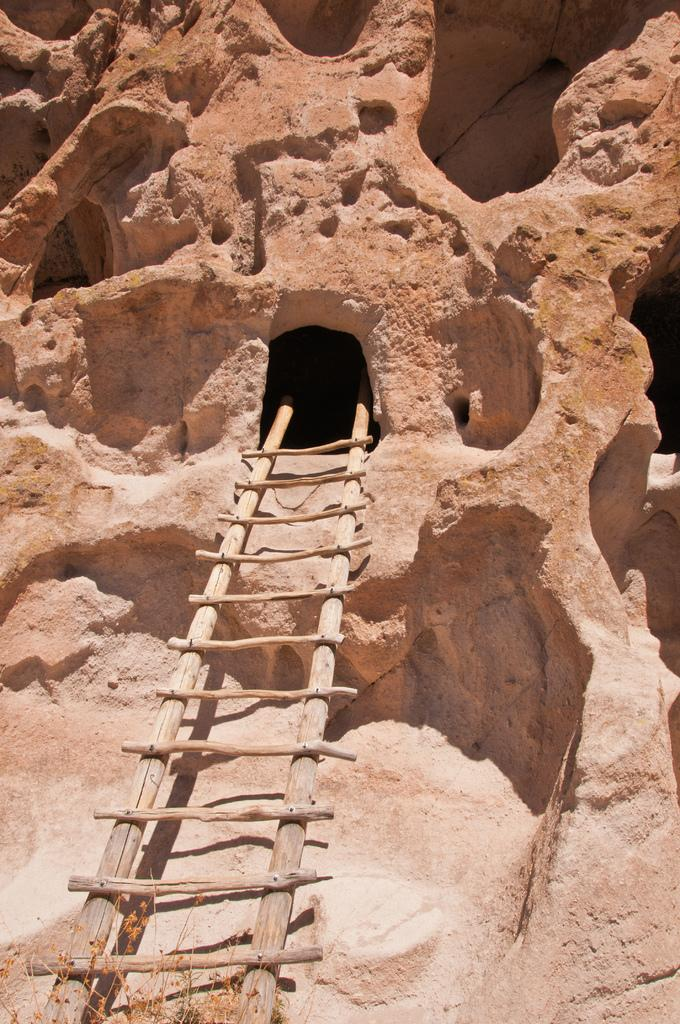What object is present in the image that can be used for climbing? There is a ladder in the image. Where does the ladder lead to? The ladder leads to a cave. How many clocks can be seen hanging on the wall inside the cave? There are no clocks visible in the image, as it only shows a ladder leading to a cave. 